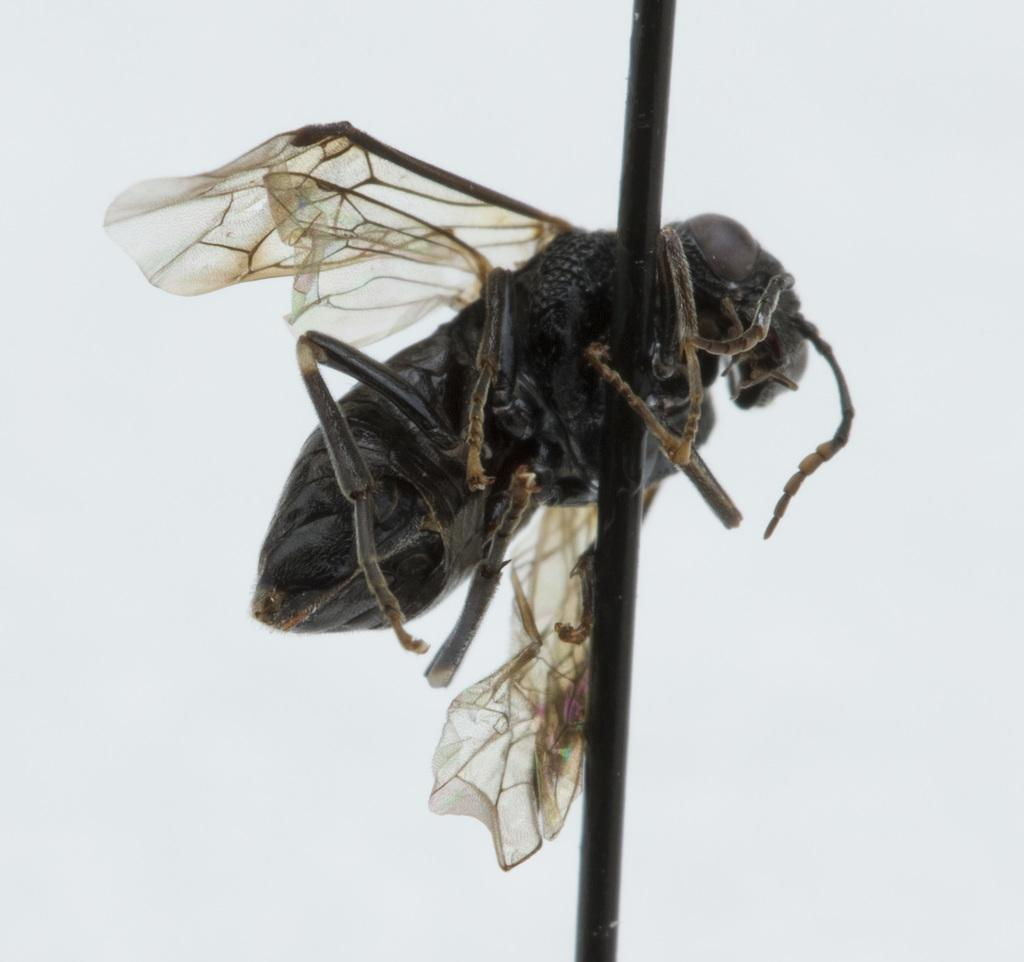What is on the pole in the image? There is a house fly on a pole in the image. What color is the background of the image? The background of the image is white. What type of waste can be seen in the image? There is no waste present in the image; it features a house fly on a pole with a white background. What is the voice of the house fly in the image? The image is a still image and does not capture any sound or voice, including that of the house fly. 